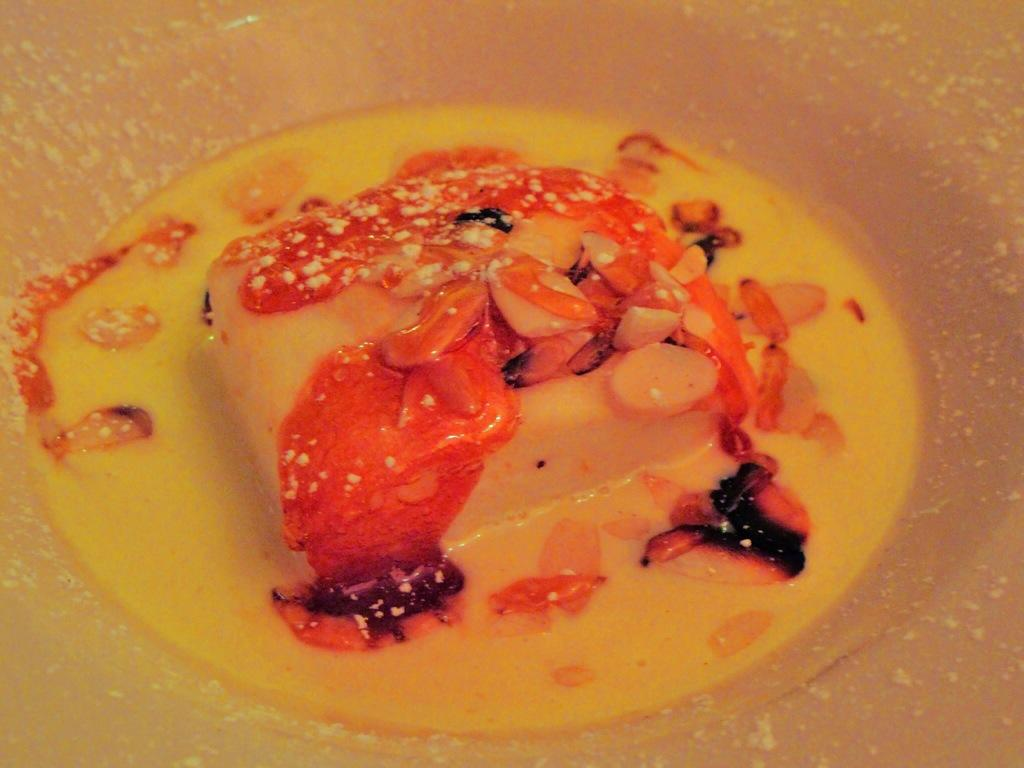What is present in the image? There is a bowl in the image. What is inside the bowl? The bowl contains food. What type of account is associated with the bowl in the image? There is no account associated with the bowl in the image. 